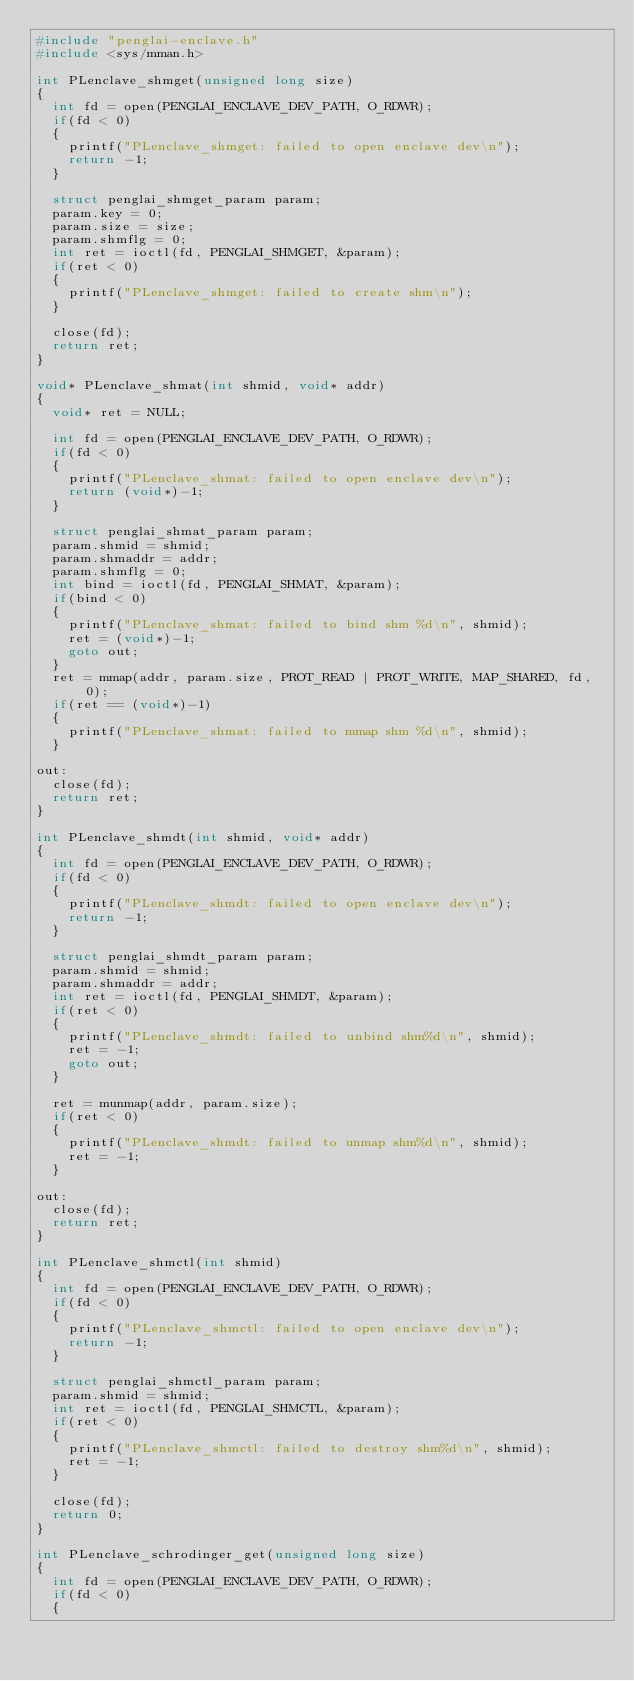Convert code to text. <code><loc_0><loc_0><loc_500><loc_500><_C_>#include "penglai-enclave.h"
#include <sys/mman.h>

int PLenclave_shmget(unsigned long size)
{
  int fd = open(PENGLAI_ENCLAVE_DEV_PATH, O_RDWR);
  if(fd < 0)
  {
    printf("PLenclave_shmget: failed to open enclave dev\n");
    return -1;
  }

  struct penglai_shmget_param param;
  param.key = 0;
  param.size = size;
  param.shmflg = 0;
  int ret = ioctl(fd, PENGLAI_SHMGET, &param);
  if(ret < 0)
  {
    printf("PLenclave_shmget: failed to create shm\n");
  }

  close(fd);
  return ret;
}

void* PLenclave_shmat(int shmid, void* addr)
{
  void* ret = NULL;

  int fd = open(PENGLAI_ENCLAVE_DEV_PATH, O_RDWR);
  if(fd < 0)
  {
    printf("PLenclave_shmat: failed to open enclave dev\n");
    return (void*)-1;
  }

  struct penglai_shmat_param param;
  param.shmid = shmid;
  param.shmaddr = addr;
  param.shmflg = 0;
  int bind = ioctl(fd, PENGLAI_SHMAT, &param);
  if(bind < 0)
  {
    printf("PLenclave_shmat: failed to bind shm %d\n", shmid);
    ret = (void*)-1;
    goto out;
  }
  ret = mmap(addr, param.size, PROT_READ | PROT_WRITE, MAP_SHARED, fd, 0);
  if(ret == (void*)-1)
  {
    printf("PLenclave_shmat: failed to mmap shm %d\n", shmid);
  }

out:
  close(fd);
  return ret;
}

int PLenclave_shmdt(int shmid, void* addr)
{
  int fd = open(PENGLAI_ENCLAVE_DEV_PATH, O_RDWR);
  if(fd < 0)
  {
    printf("PLenclave_shmdt: failed to open enclave dev\n");
    return -1;
  }

  struct penglai_shmdt_param param;
  param.shmid = shmid;
  param.shmaddr = addr;
  int ret = ioctl(fd, PENGLAI_SHMDT, &param);
  if(ret < 0)
  {
    printf("PLenclave_shmdt: failed to unbind shm%d\n", shmid);
    ret = -1;
    goto out;
  }

  ret = munmap(addr, param.size);
  if(ret < 0)
  {
    printf("PLenclave_shmdt: failed to unmap shm%d\n", shmid);
    ret = -1;
  }

out:
  close(fd);
  return ret;
}

int PLenclave_shmctl(int shmid)
{
  int fd = open(PENGLAI_ENCLAVE_DEV_PATH, O_RDWR);
  if(fd < 0)
  {
    printf("PLenclave_shmctl: failed to open enclave dev\n");
    return -1;
  }

  struct penglai_shmctl_param param;
  param.shmid = shmid;
  int ret = ioctl(fd, PENGLAI_SHMCTL, &param);
  if(ret < 0)
  {
    printf("PLenclave_shmctl: failed to destroy shm%d\n", shmid);
    ret = -1;
  }

  close(fd);
  return 0;
}

int PLenclave_schrodinger_get(unsigned long size)
{
  int fd = open(PENGLAI_ENCLAVE_DEV_PATH, O_RDWR);
  if(fd < 0)
  {</code> 